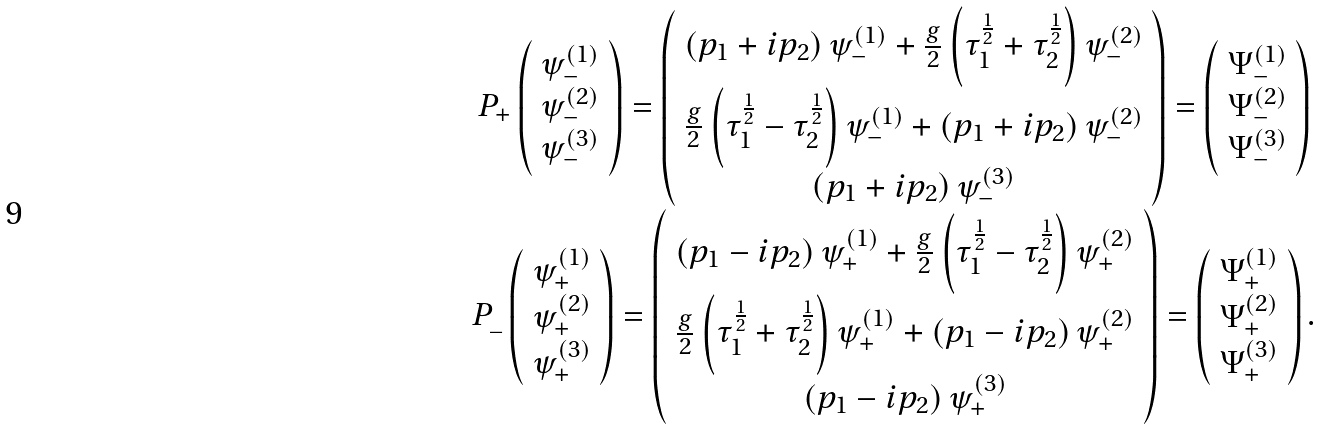Convert formula to latex. <formula><loc_0><loc_0><loc_500><loc_500>\begin{array} { c } P _ { + } \left ( \begin{array} { c } \psi _ { - } ^ { ( 1 ) } \\ \psi _ { - } ^ { ( 2 ) } \\ \psi _ { - } ^ { ( 3 ) } \end{array} \right ) = \left ( \begin{array} { c } \left ( p _ { 1 } + i p _ { 2 } \right ) \psi _ { - } ^ { ( 1 ) } + \frac { g } { 2 } \left ( \tau _ { 1 } ^ { \frac { 1 } { 2 } } + \tau _ { 2 } ^ { \frac { 1 } { 2 } } \right ) \psi _ { - } ^ { ( 2 ) } \\ \frac { g } { 2 } \left ( \tau _ { 1 } ^ { \frac { 1 } { 2 } } - \tau _ { 2 } ^ { \frac { 1 } { 2 } } \right ) \psi _ { - } ^ { ( 1 ) } + \left ( p _ { 1 } + i p _ { 2 } \right ) \psi _ { - } ^ { ( 2 ) } \\ \left ( p _ { 1 } + i p _ { 2 } \right ) \psi _ { - } ^ { ( 3 ) } \end{array} \right ) = \left ( \begin{array} { c } \Psi _ { - } ^ { ( 1 ) } \\ \Psi _ { - } ^ { ( 2 ) } \\ \Psi _ { - } ^ { ( 3 ) } \end{array} \right ) \\ P _ { \_ } \left ( \begin{array} { c } \psi _ { + } ^ { ( 1 ) } \\ \psi _ { + } ^ { ( 2 ) } \\ \psi _ { + } ^ { ( 3 ) } \end{array} \right ) = \left ( \begin{array} { c } \left ( p _ { 1 } - i p _ { 2 } \right ) \psi _ { + } ^ { ( 1 ) } + \frac { g } { 2 } \left ( \tau _ { 1 } ^ { \frac { 1 } { 2 } } - \tau _ { 2 } ^ { \frac { 1 } { 2 } } \right ) \psi _ { + } ^ { ( 2 ) } \\ \frac { g } { 2 } \left ( \tau _ { 1 } ^ { \frac { 1 } { 2 } } + \tau _ { 2 } ^ { \frac { 1 } { 2 } } \right ) \psi _ { + } ^ { ( 1 ) } + \left ( p _ { 1 } - i p _ { 2 } \right ) \psi _ { + } ^ { ( 2 ) } \\ \left ( p _ { 1 } - i p _ { 2 } \right ) \psi _ { + } ^ { ( 3 ) } \end{array} \right ) = \left ( \begin{array} { c } \Psi _ { + } ^ { ( 1 ) } \\ \Psi _ { + } ^ { ( 2 ) } \\ \Psi _ { + } ^ { ( 3 ) } \end{array} \right ) . \end{array}</formula> 